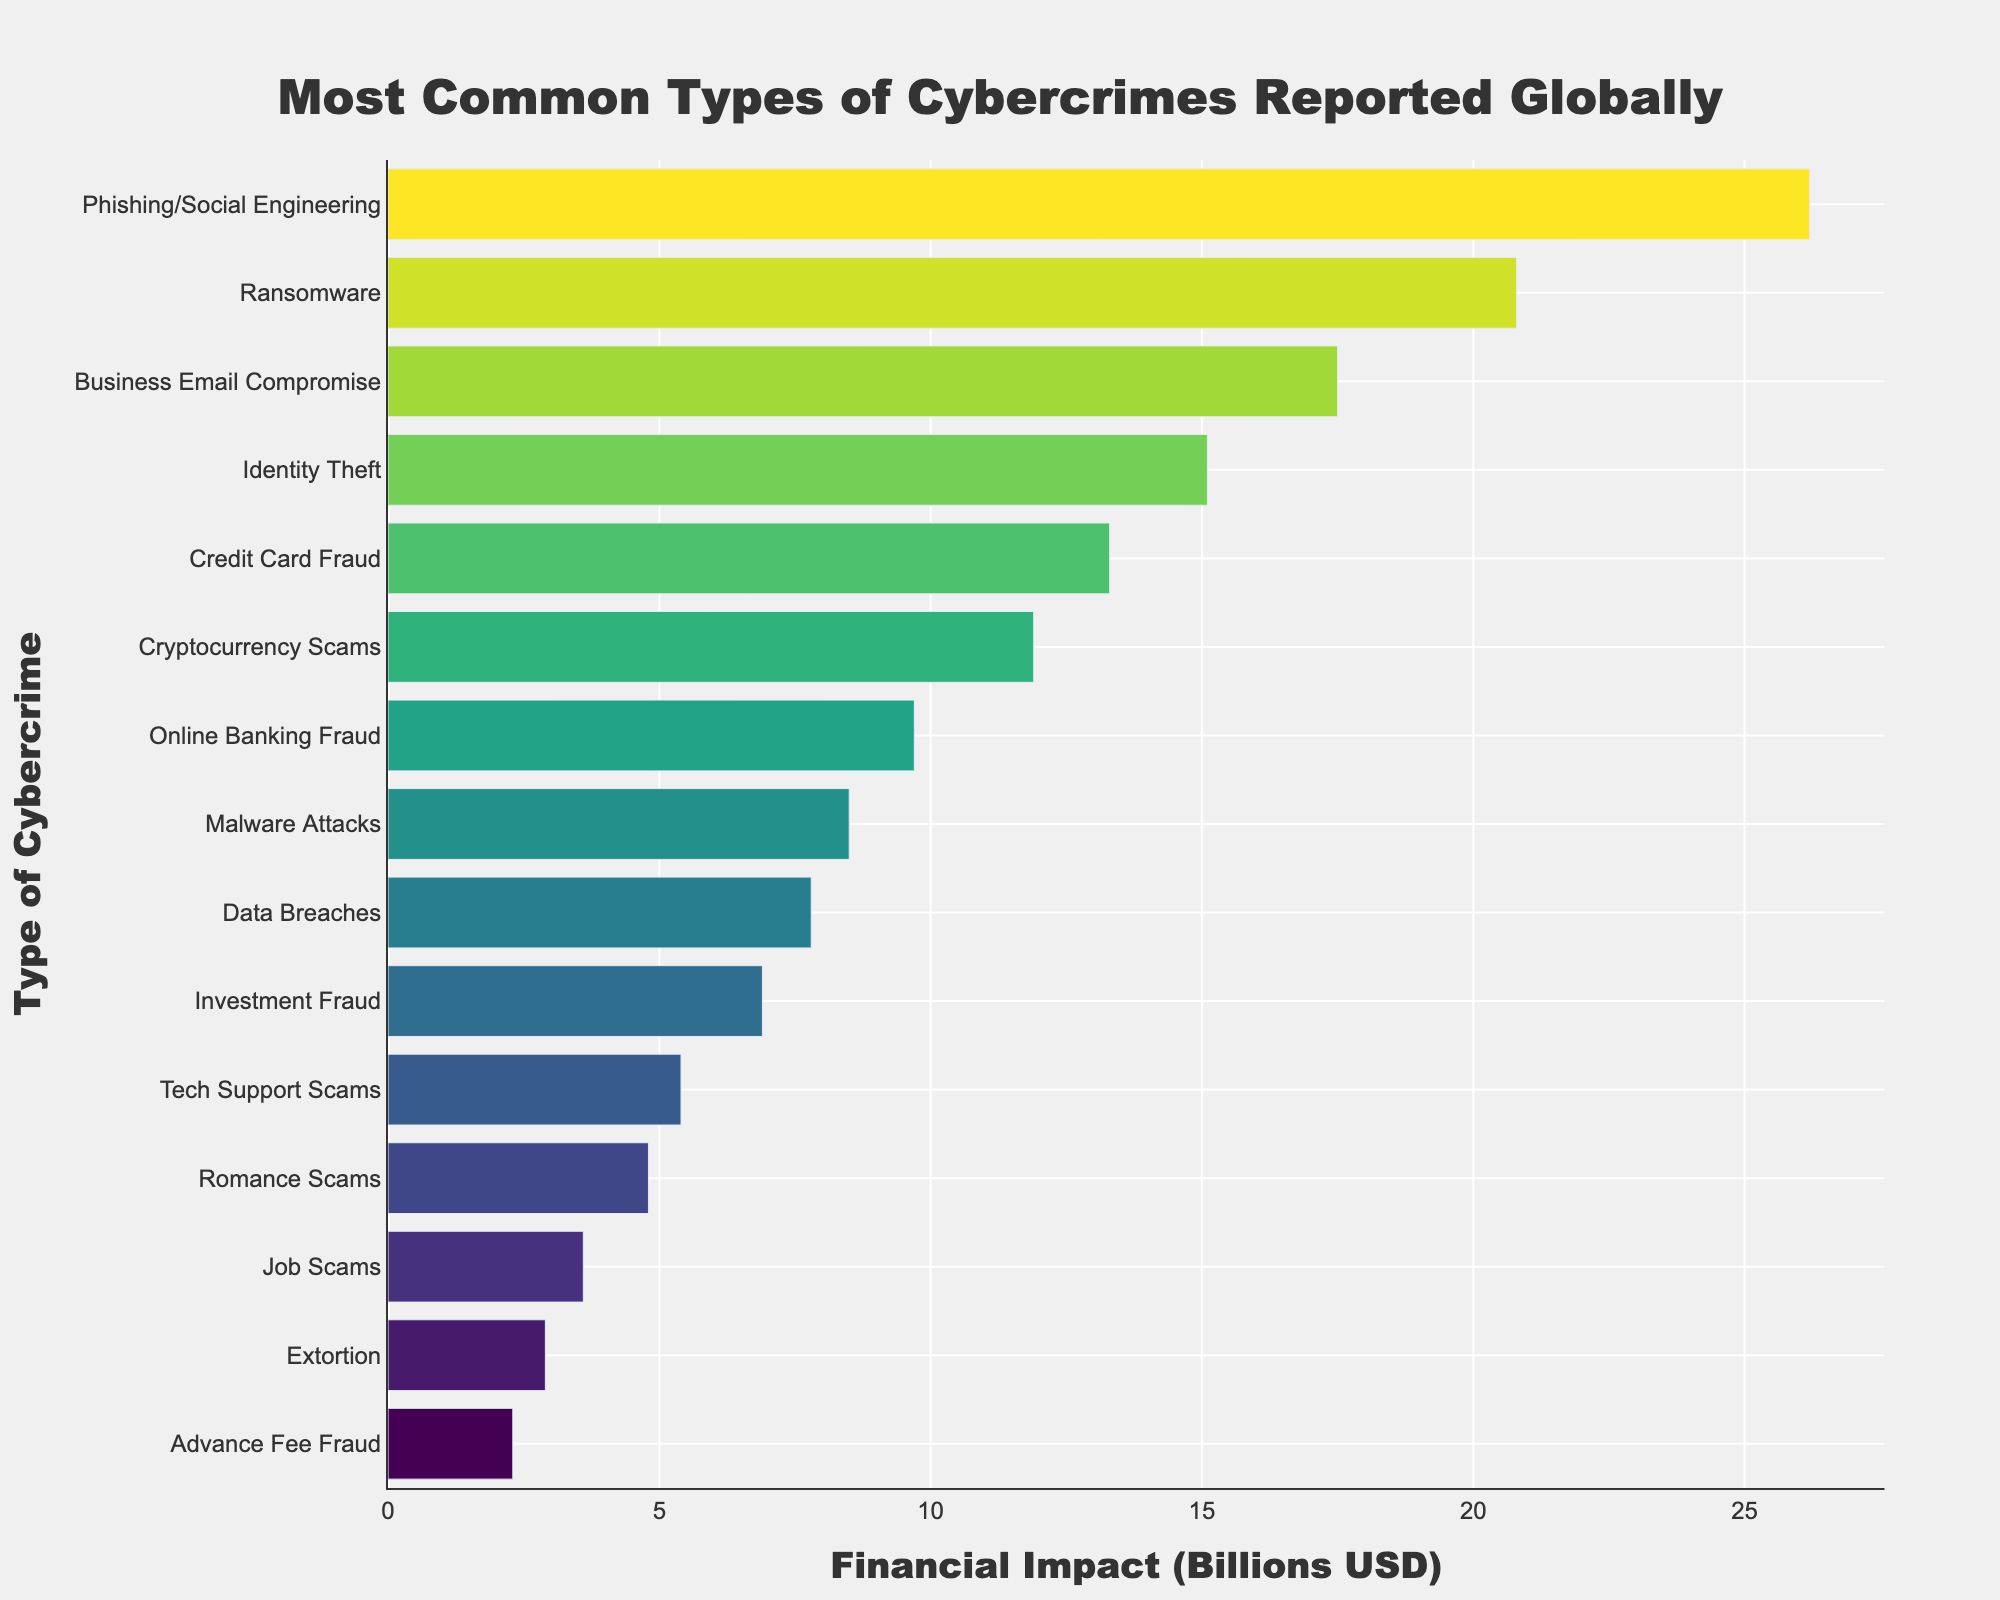Which type of cybercrime has the highest financial impact? The cybercrime type with the highest financial impact is the one with the longest bar. In this case, it is "Phishing/Social Engineering" at $26.2 billion.
Answer: Phishing/Social Engineering Which type of cybercrime has a financial impact less than $4 billion? By observing the lengths of the bars, the bars shorter than the $4 billion mark correspond to "Romance Scams," "Job Scams," "Extortion," and "Advance Fee Fraud."
Answer: Romance Scams, Job Scams, Extortion, Advance Fee Fraud How much more financial impact does Phishing/Social Engineering have compared to Ransomware? Phishing/Social Engineering has a financial impact of $26.2 billion, and Ransomware has $20.8 billion. The difference is $26.2 billion - $20.8 billion = $5.4 billion.
Answer: $5.4 billion Which cybercrime types have a financial impact between $10 billion and $15 billion? Look for bars where the financial impact values fall between $10 billion and $15 billion. The relevant cybercrimes are "Identity Theft" at $15.1 billion, "Credit Card Fraud" at $13.3 billion, and "Cryptocurrency Scams" at $11.9 billion.
Answer: Identity Theft, Credit Card Fraud, Cryptocurrency Scams Which cybercrimes have a nearly equal financial impact? Look at the bars whose ends are close to each other on the x-axis (in terms of financial impact). "Credit Card Fraud" ($13.3 billion) and "Cryptocurrency Scams" ($11.9 billion) have nearly equal impacts.
Answer: Credit Card Fraud, Cryptocurrency Scams What is the total financial impact of the top three most impactful cybercrimes? Sum up the financial impact of the top three most impactful cybercrimes: $26.2 billion (Phishing/Social Engineering) + $20.8 billion (Ransomware) + $17.5 billion (Business Email Compromise). The total is $26.2 billion + $20.8 billion + $17.5 billion = $64.5 billion.
Answer: $64.5 billion What's the average financial impact of the ten least impactful cybercrimes listed? Add up the financial impacts of the ten least impactful cybercrimes and then divide by 10. Their total impact is: $5.4 billion + $4.8 billion + $3.6 billion + $2.9 billion + $2.3 billion + $7.8 billion + $8.5 billion + $9.7 billion + $11.9 billion + $13.3 billion = $70.2 billion. The average is $70.2 billion / 10 = $7.02 billion.
Answer: $7.02 billion Compare the financial impact of Malware Attacks to Data Breaches. Which one is higher and by how much? Malware Attacks have a financial impact of $8.5 billion, and Data Breaches have $7.8 billion. The difference is $8.5 billion - $7.8 billion = $0.7 billion, so Malware Attacks have a $0.7 billion higher impact.
Answer: Malware Attacks by $0.7 billion 